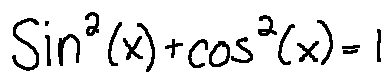Convert formula to latex. <formula><loc_0><loc_0><loc_500><loc_500>\sin ^ { 2 } ( x ) + \cos ^ { 2 } ( x ) = 1</formula> 